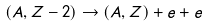<formula> <loc_0><loc_0><loc_500><loc_500>( A , Z - 2 ) \rightarrow ( A , Z ) + e + e</formula> 